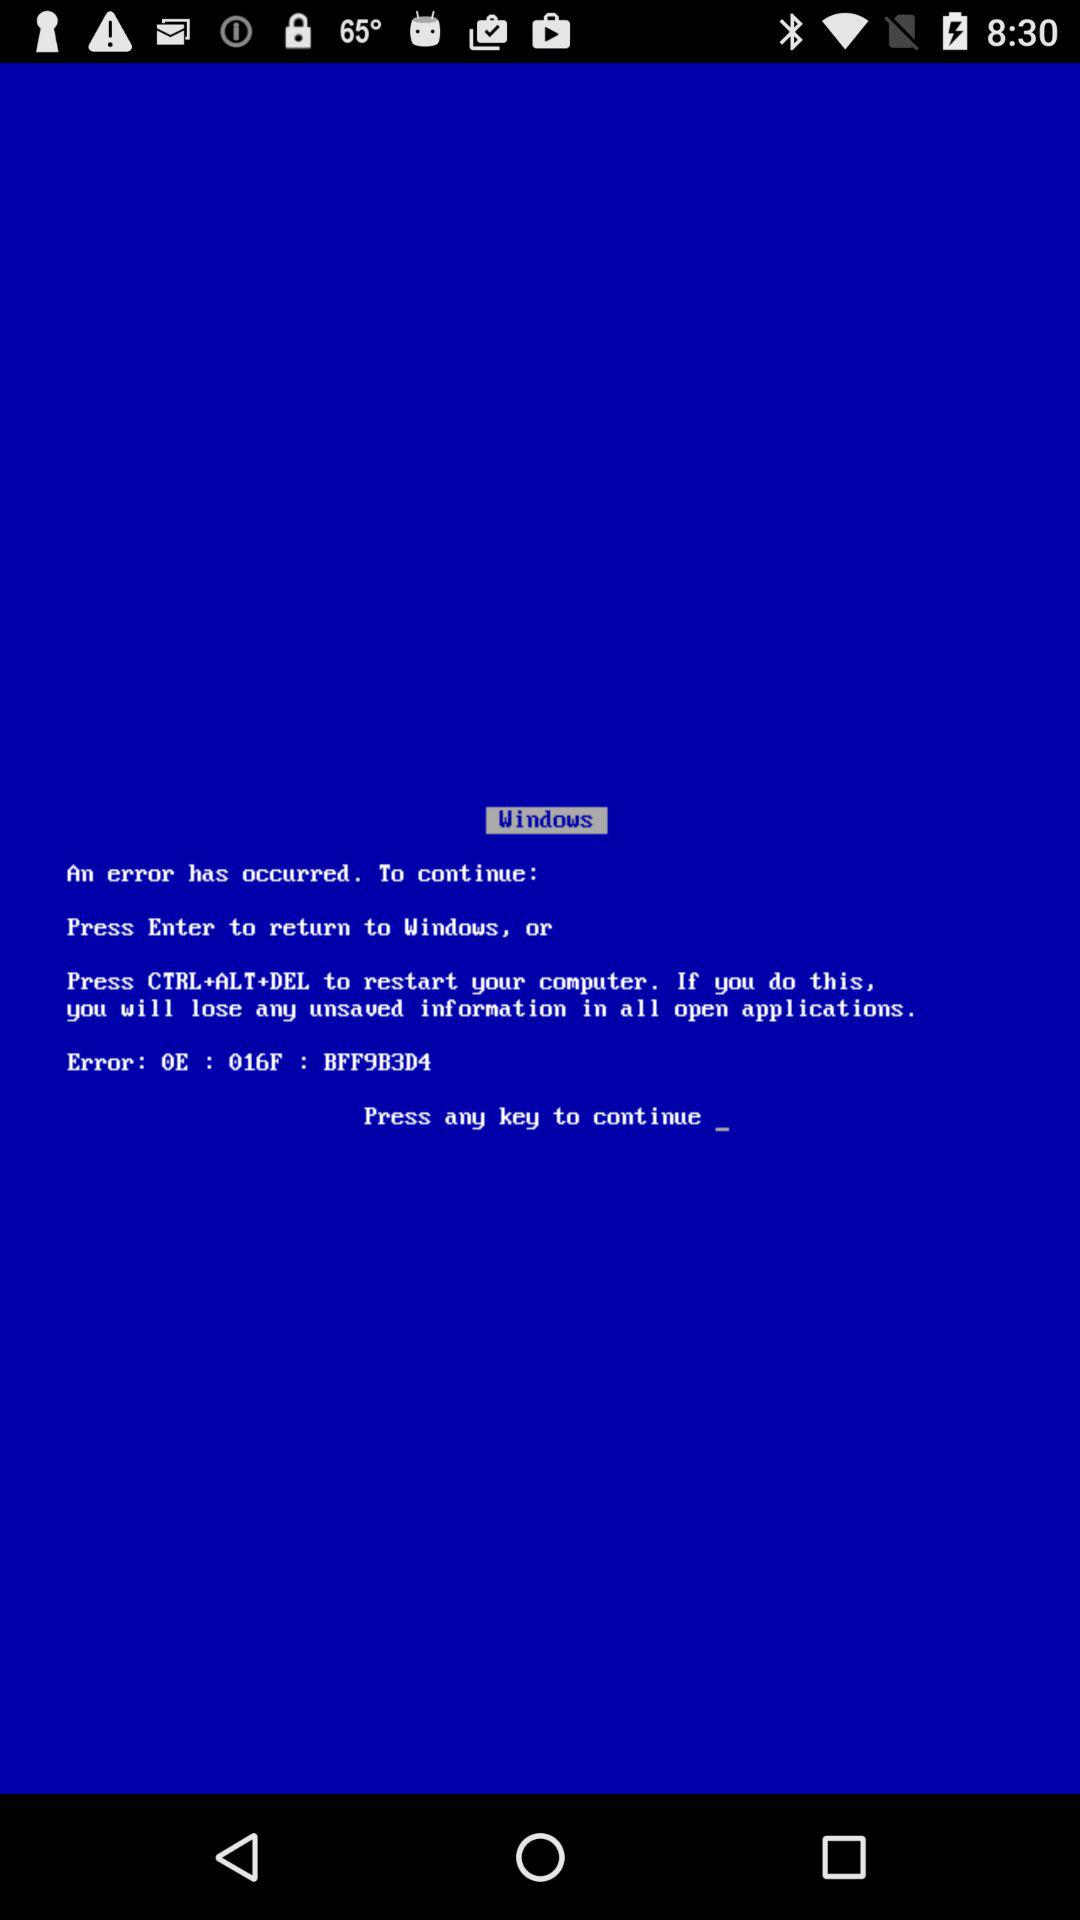What's the short-cut to restarting the computer? To restart the computer, press CTRL+ALT+DEL. 